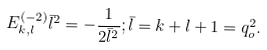<formula> <loc_0><loc_0><loc_500><loc_500>E _ { k , l } ^ { ( - 2 ) } \bar { l } ^ { 2 } = - \frac { 1 } { 2 \bar { l } ^ { 2 } } ; \bar { l } = k + l + 1 = q _ { o } ^ { 2 } .</formula> 